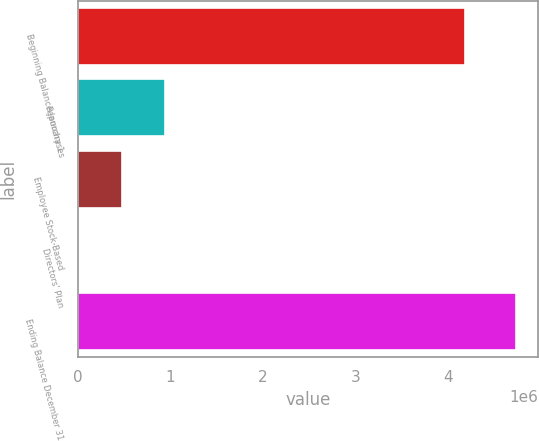<chart> <loc_0><loc_0><loc_500><loc_500><bar_chart><fcel>Beginning Balance January 1<fcel>Repurchases<fcel>Employee Stock-Based<fcel>Directors' Plan<fcel>Ending Balance December 31<nl><fcel>4.17521e+06<fcel>945694<fcel>473010<fcel>326<fcel>4.72717e+06<nl></chart> 